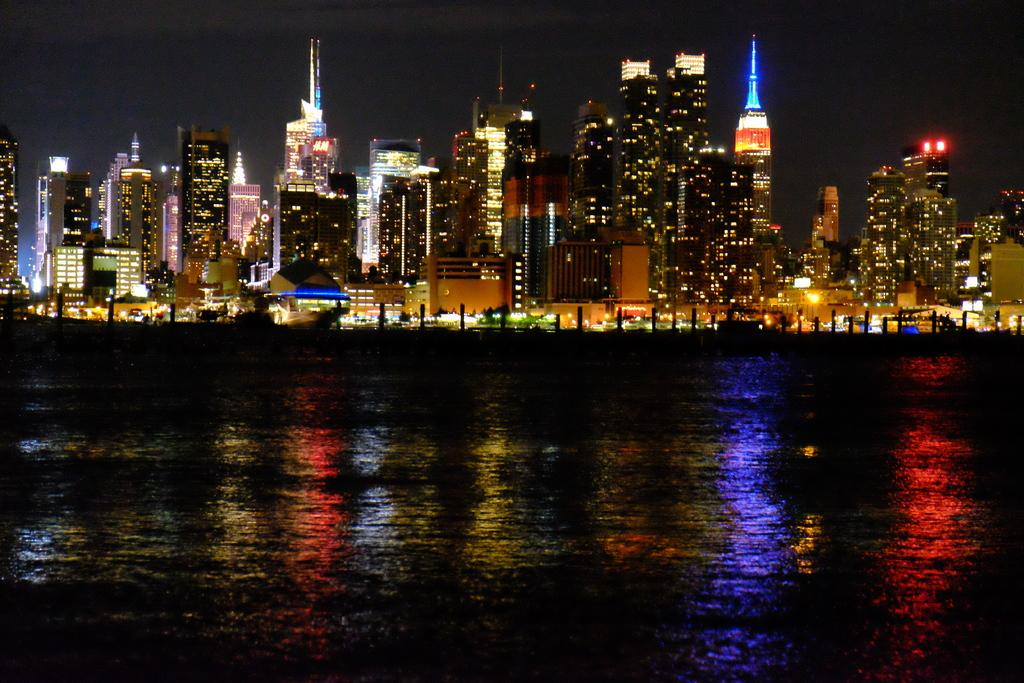What time of day is depicted in the image? The image depicts a night view. What structures can be seen in the image? There are buildings in the image. Where are the buildings located in relation to the river? The buildings are alongside a river. What is the value of the alarm clock in the image? There is no alarm clock present in the image. Can you see any ghosts in the image? There are no ghosts depicted in the image. 